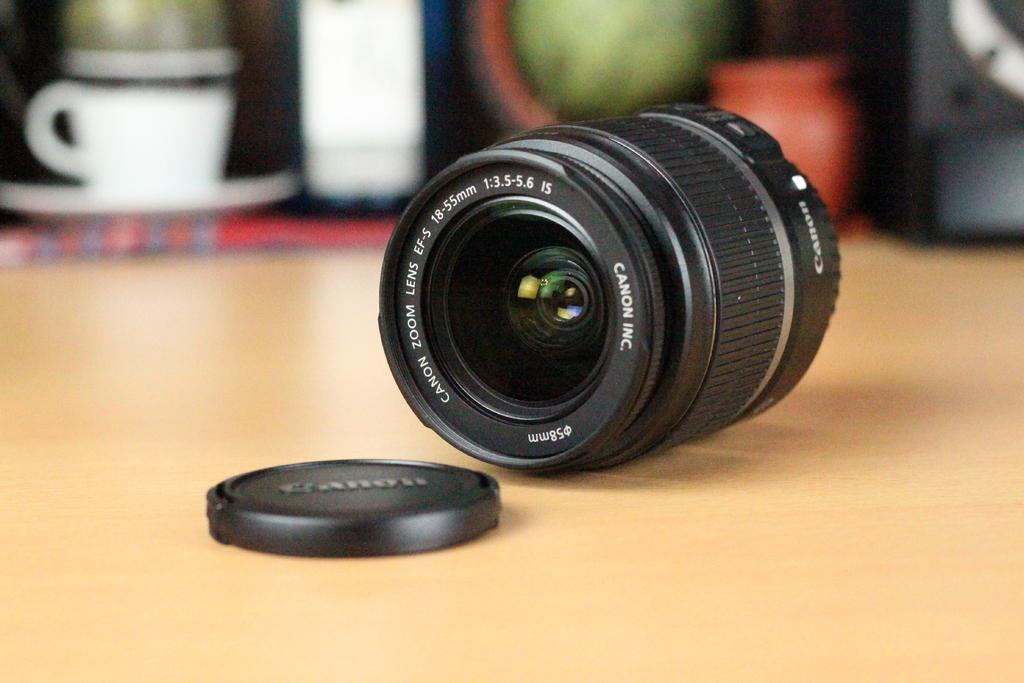What is the main object on the table in the image? There is a camera on the table in the image. What else can be seen on the table besides the camera? There is a cup and saucer on the table. How would you describe the background of the image? The background of the image is slightly blurred. What type of print is visible on the camera in the image? There is no print visible on the camera in the image. What substance is being used to clean the camera in the image? There is no substance being used to clean the camera in the image. 